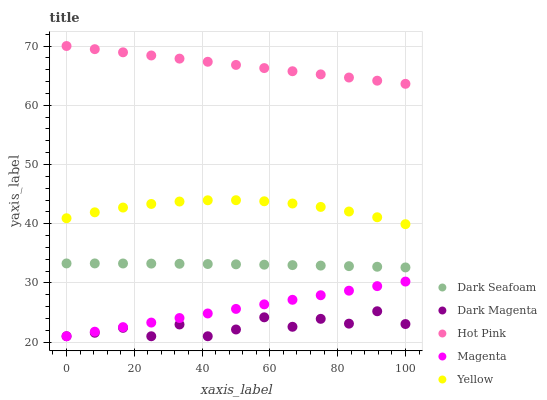Does Dark Magenta have the minimum area under the curve?
Answer yes or no. Yes. Does Hot Pink have the maximum area under the curve?
Answer yes or no. Yes. Does Yellow have the minimum area under the curve?
Answer yes or no. No. Does Yellow have the maximum area under the curve?
Answer yes or no. No. Is Magenta the smoothest?
Answer yes or no. Yes. Is Dark Magenta the roughest?
Answer yes or no. Yes. Is Hot Pink the smoothest?
Answer yes or no. No. Is Hot Pink the roughest?
Answer yes or no. No. Does Dark Magenta have the lowest value?
Answer yes or no. Yes. Does Yellow have the lowest value?
Answer yes or no. No. Does Hot Pink have the highest value?
Answer yes or no. Yes. Does Yellow have the highest value?
Answer yes or no. No. Is Dark Magenta less than Dark Seafoam?
Answer yes or no. Yes. Is Hot Pink greater than Magenta?
Answer yes or no. Yes. Does Dark Magenta intersect Magenta?
Answer yes or no. Yes. Is Dark Magenta less than Magenta?
Answer yes or no. No. Is Dark Magenta greater than Magenta?
Answer yes or no. No. Does Dark Magenta intersect Dark Seafoam?
Answer yes or no. No. 